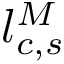Convert formula to latex. <formula><loc_0><loc_0><loc_500><loc_500>l _ { c , s } ^ { M }</formula> 